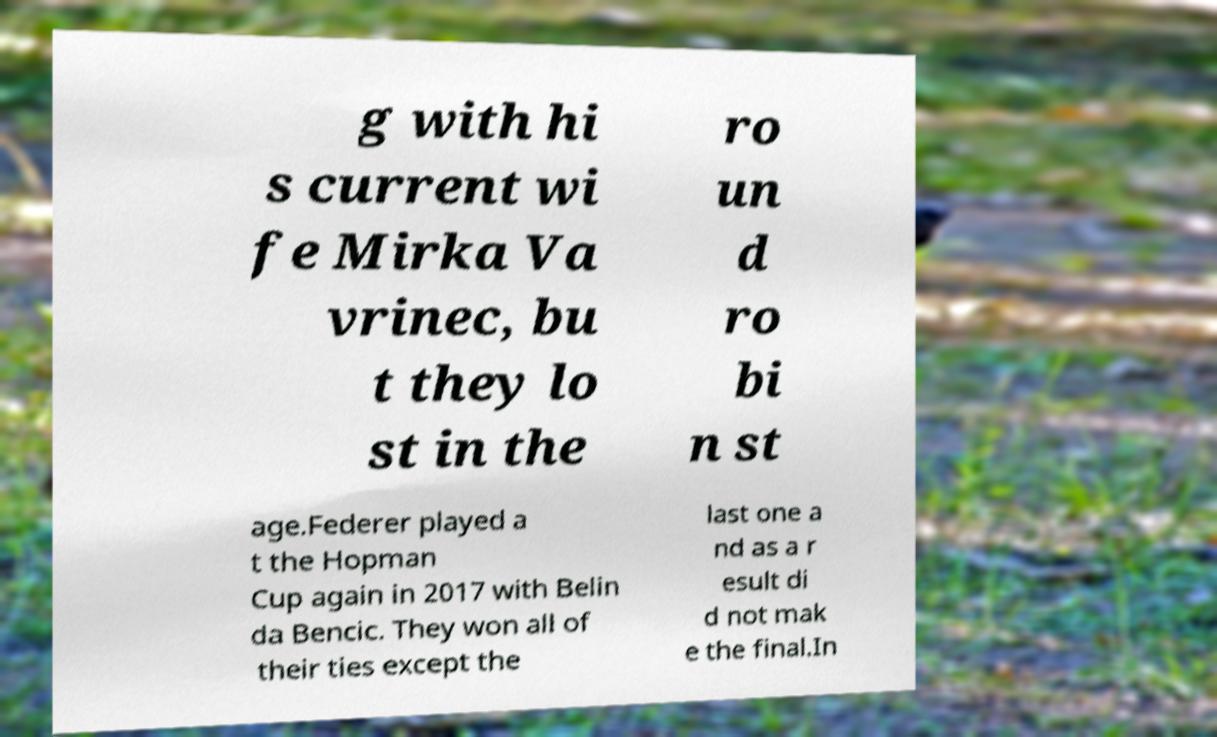Could you assist in decoding the text presented in this image and type it out clearly? g with hi s current wi fe Mirka Va vrinec, bu t they lo st in the ro un d ro bi n st age.Federer played a t the Hopman Cup again in 2017 with Belin da Bencic. They won all of their ties except the last one a nd as a r esult di d not mak e the final.In 